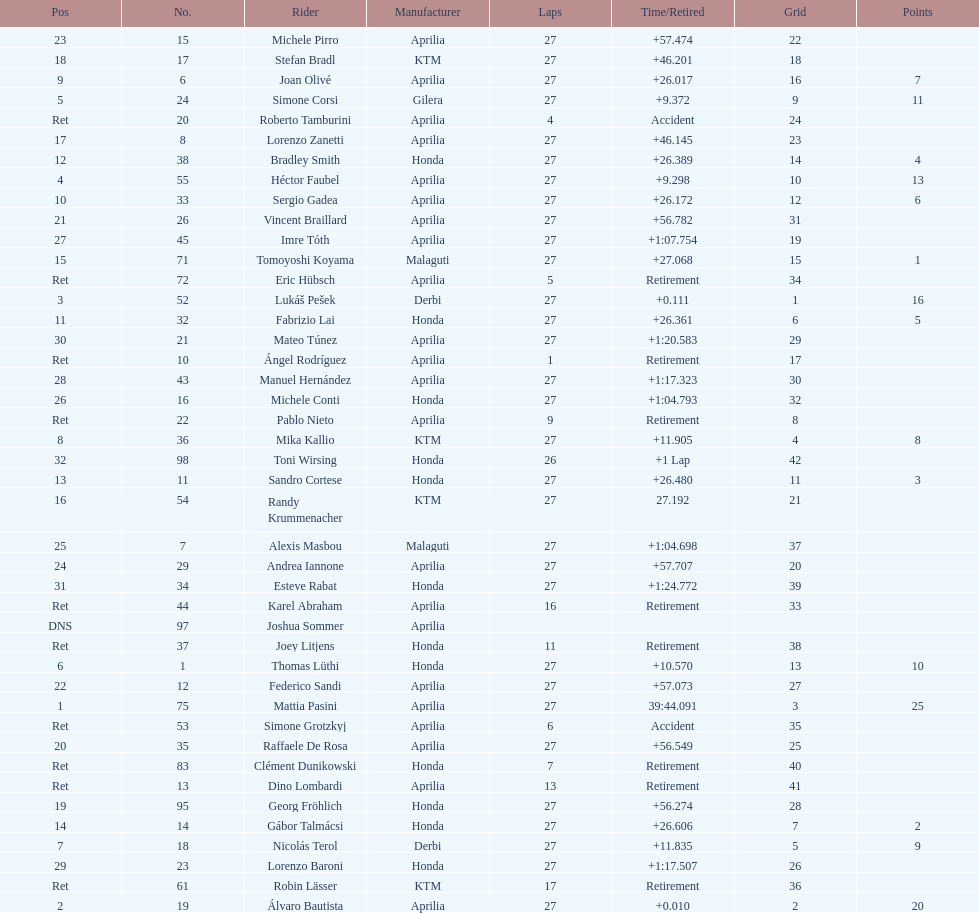Name a racer that had at least 20 points. Mattia Pasini. 